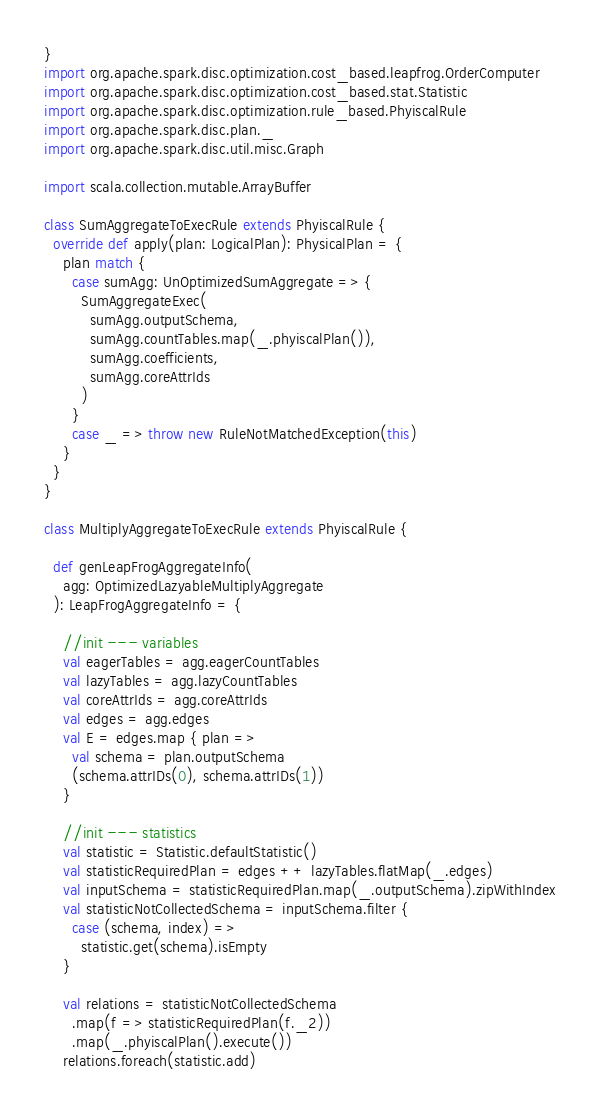<code> <loc_0><loc_0><loc_500><loc_500><_Scala_>}
import org.apache.spark.disc.optimization.cost_based.leapfrog.OrderComputer
import org.apache.spark.disc.optimization.cost_based.stat.Statistic
import org.apache.spark.disc.optimization.rule_based.PhyiscalRule
import org.apache.spark.disc.plan._
import org.apache.spark.disc.util.misc.Graph

import scala.collection.mutable.ArrayBuffer

class SumAggregateToExecRule extends PhyiscalRule {
  override def apply(plan: LogicalPlan): PhysicalPlan = {
    plan match {
      case sumAgg: UnOptimizedSumAggregate => {
        SumAggregateExec(
          sumAgg.outputSchema,
          sumAgg.countTables.map(_.phyiscalPlan()),
          sumAgg.coefficients,
          sumAgg.coreAttrIds
        )
      }
      case _ => throw new RuleNotMatchedException(this)
    }
  }
}

class MultiplyAggregateToExecRule extends PhyiscalRule {

  def genLeapFrogAggregateInfo(
    agg: OptimizedLazyableMultiplyAggregate
  ): LeapFrogAggregateInfo = {

    //init --- variables
    val eagerTables = agg.eagerCountTables
    val lazyTables = agg.lazyCountTables
    val coreAttrIds = agg.coreAttrIds
    val edges = agg.edges
    val E = edges.map { plan =>
      val schema = plan.outputSchema
      (schema.attrIDs(0), schema.attrIDs(1))
    }

    //init --- statistics
    val statistic = Statistic.defaultStatistic()
    val statisticRequiredPlan = edges ++ lazyTables.flatMap(_.edges)
    val inputSchema = statisticRequiredPlan.map(_.outputSchema).zipWithIndex
    val statisticNotCollectedSchema = inputSchema.filter {
      case (schema, index) =>
        statistic.get(schema).isEmpty
    }

    val relations = statisticNotCollectedSchema
      .map(f => statisticRequiredPlan(f._2))
      .map(_.phyiscalPlan().execute())
    relations.foreach(statistic.add)
</code> 